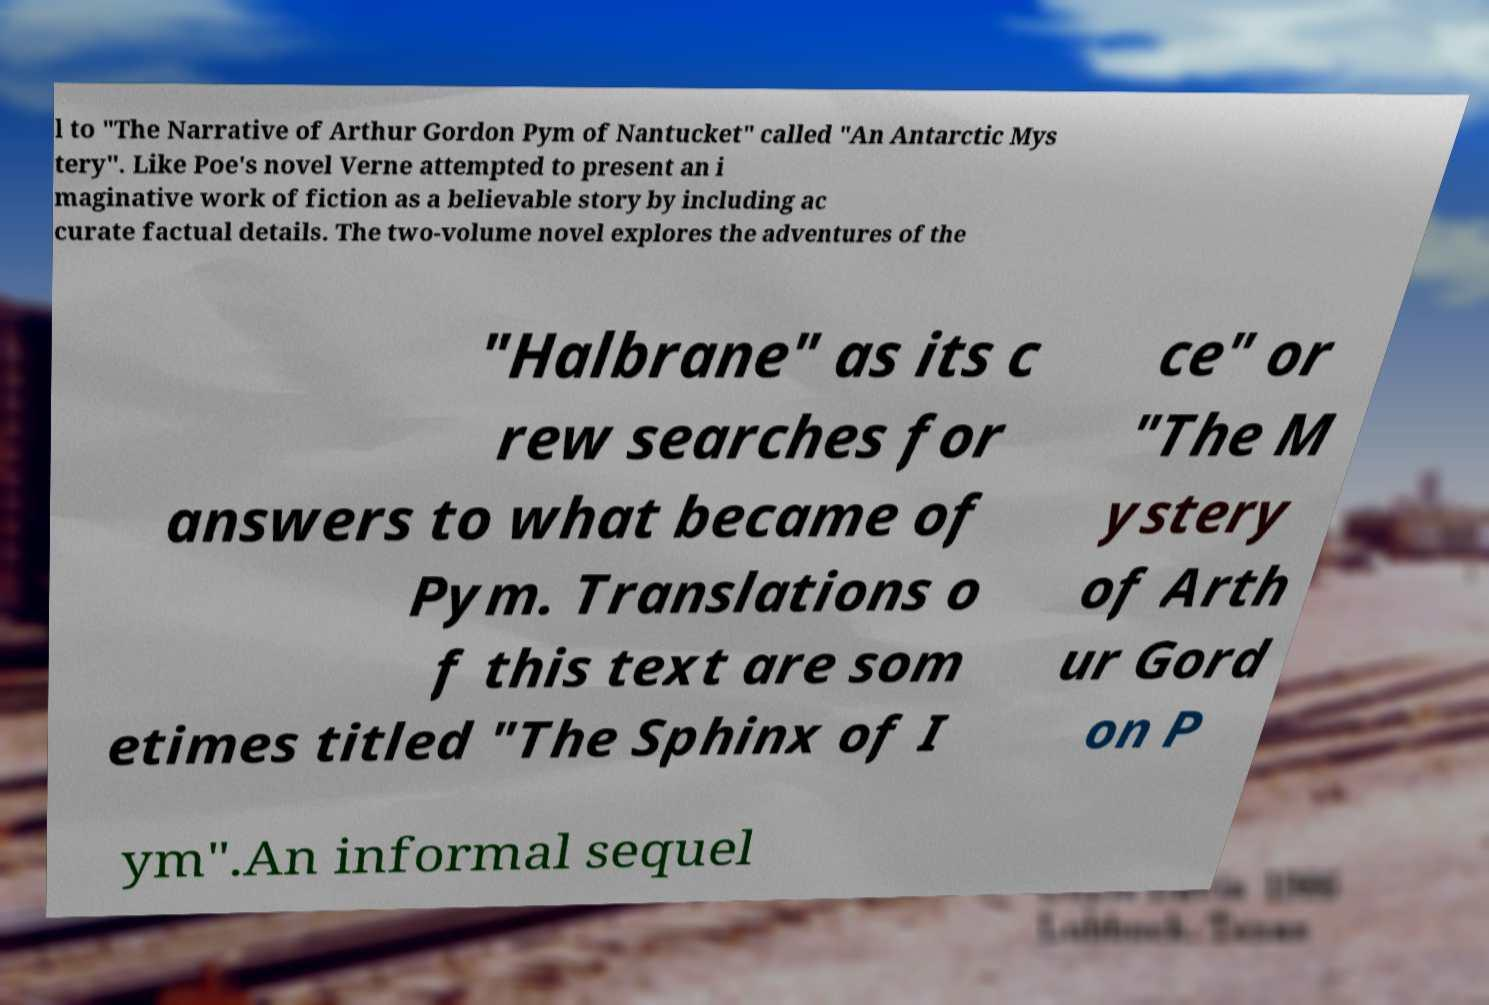Could you extract and type out the text from this image? l to "The Narrative of Arthur Gordon Pym of Nantucket" called "An Antarctic Mys tery". Like Poe's novel Verne attempted to present an i maginative work of fiction as a believable story by including ac curate factual details. The two-volume novel explores the adventures of the "Halbrane" as its c rew searches for answers to what became of Pym. Translations o f this text are som etimes titled "The Sphinx of I ce" or "The M ystery of Arth ur Gord on P ym".An informal sequel 